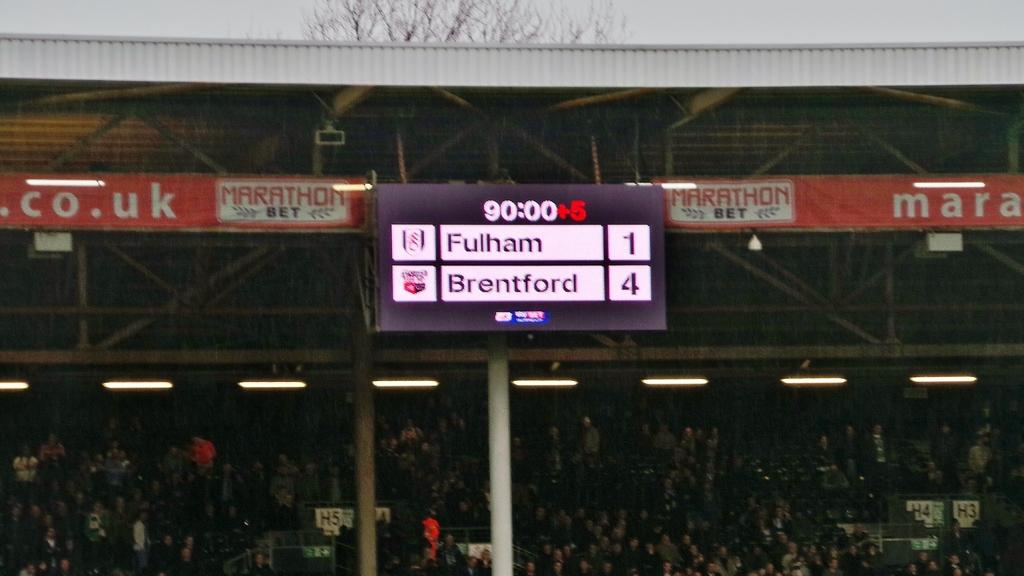<image>
Share a concise interpretation of the image provided. The score board at this match says that Fulham are on 1 and Brendford have 4. 